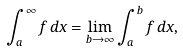Convert formula to latex. <formula><loc_0><loc_0><loc_500><loc_500>\int _ { a } ^ { \infty } f \, d x = \lim _ { b \rightarrow \infty } \int _ { a } ^ { b } f \, d x ,</formula> 